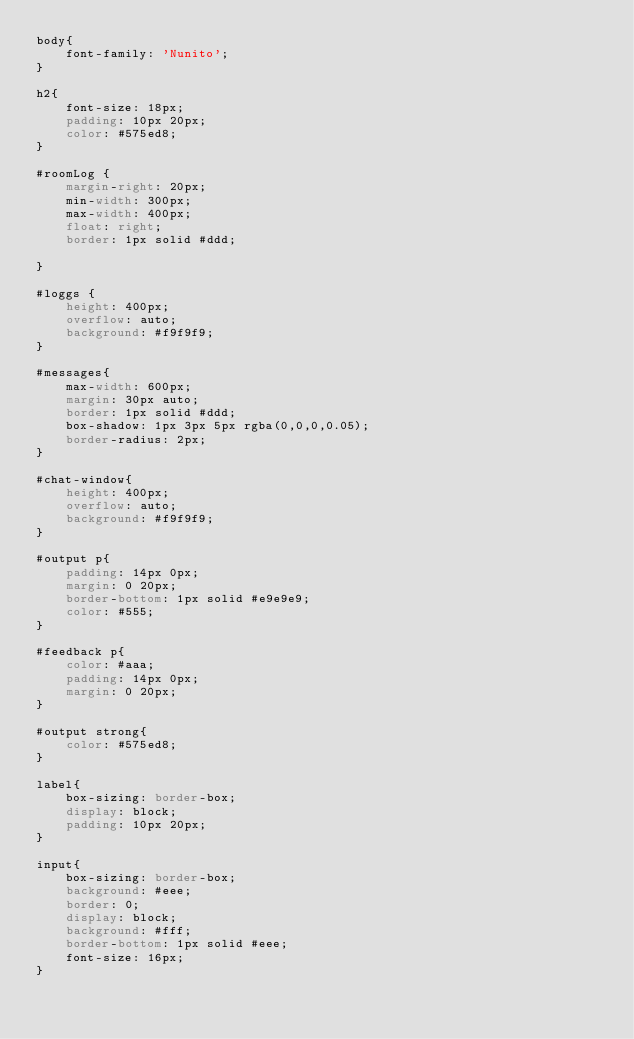Convert code to text. <code><loc_0><loc_0><loc_500><loc_500><_CSS_>body{
    font-family: 'Nunito';
}

h2{
    font-size: 18px;
    padding: 10px 20px;
    color: #575ed8;
}

#roomLog {
    margin-right: 20px;
    min-width: 300px;
    max-width: 400px;
    float: right;
    border: 1px solid #ddd;
    
}

#loggs {
    height: 400px;
    overflow: auto;
    background: #f9f9f9;
}

#messages{
    max-width: 600px;
    margin: 30px auto;
    border: 1px solid #ddd;
    box-shadow: 1px 3px 5px rgba(0,0,0,0.05);
    border-radius: 2px;
}

#chat-window{
    height: 400px;
    overflow: auto;
    background: #f9f9f9;
}

#output p{
    padding: 14px 0px;
    margin: 0 20px;
    border-bottom: 1px solid #e9e9e9;
    color: #555;
}

#feedback p{
    color: #aaa;
    padding: 14px 0px;
    margin: 0 20px;
}

#output strong{
    color: #575ed8;
}

label{
    box-sizing: border-box;
    display: block;
    padding: 10px 20px;
}

input{
    box-sizing: border-box;
    background: #eee;
    border: 0;
    display: block;
    background: #fff;
    border-bottom: 1px solid #eee;
    font-size: 16px;
}


</code> 